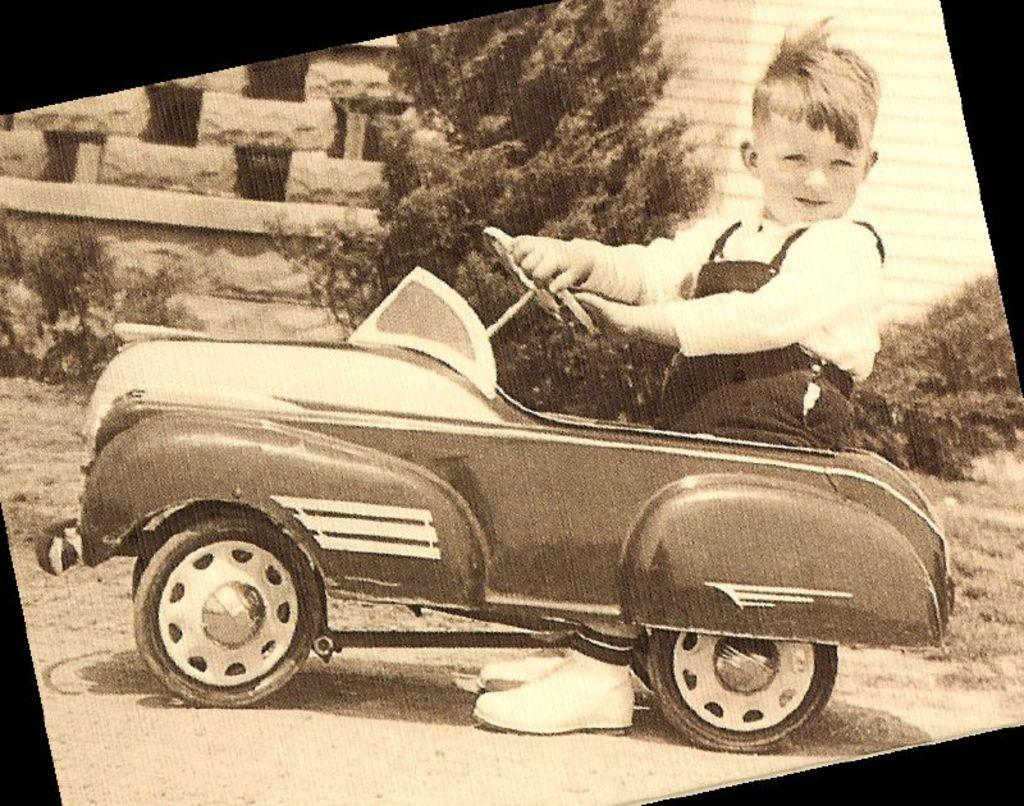Who is the main subject in the image? There is a boy in the image. What is the boy doing in the image? The boy is sitting in a toy car. What can be seen in the background of the image? There is a building and plants in the background of the image. What type of surface is visible at the bottom of the image? The ground is visible at the bottom of the image. What kind of vegetation is present on the ground? There is grass on the ground. What type of breakfast is the boy eating in the image? There is no breakfast visible in the image; the boy is sitting in a toy car. What type of bomb can be seen in the image? There is no bomb present in the image; it features a boy sitting in a toy car with a background of a building and plants. 